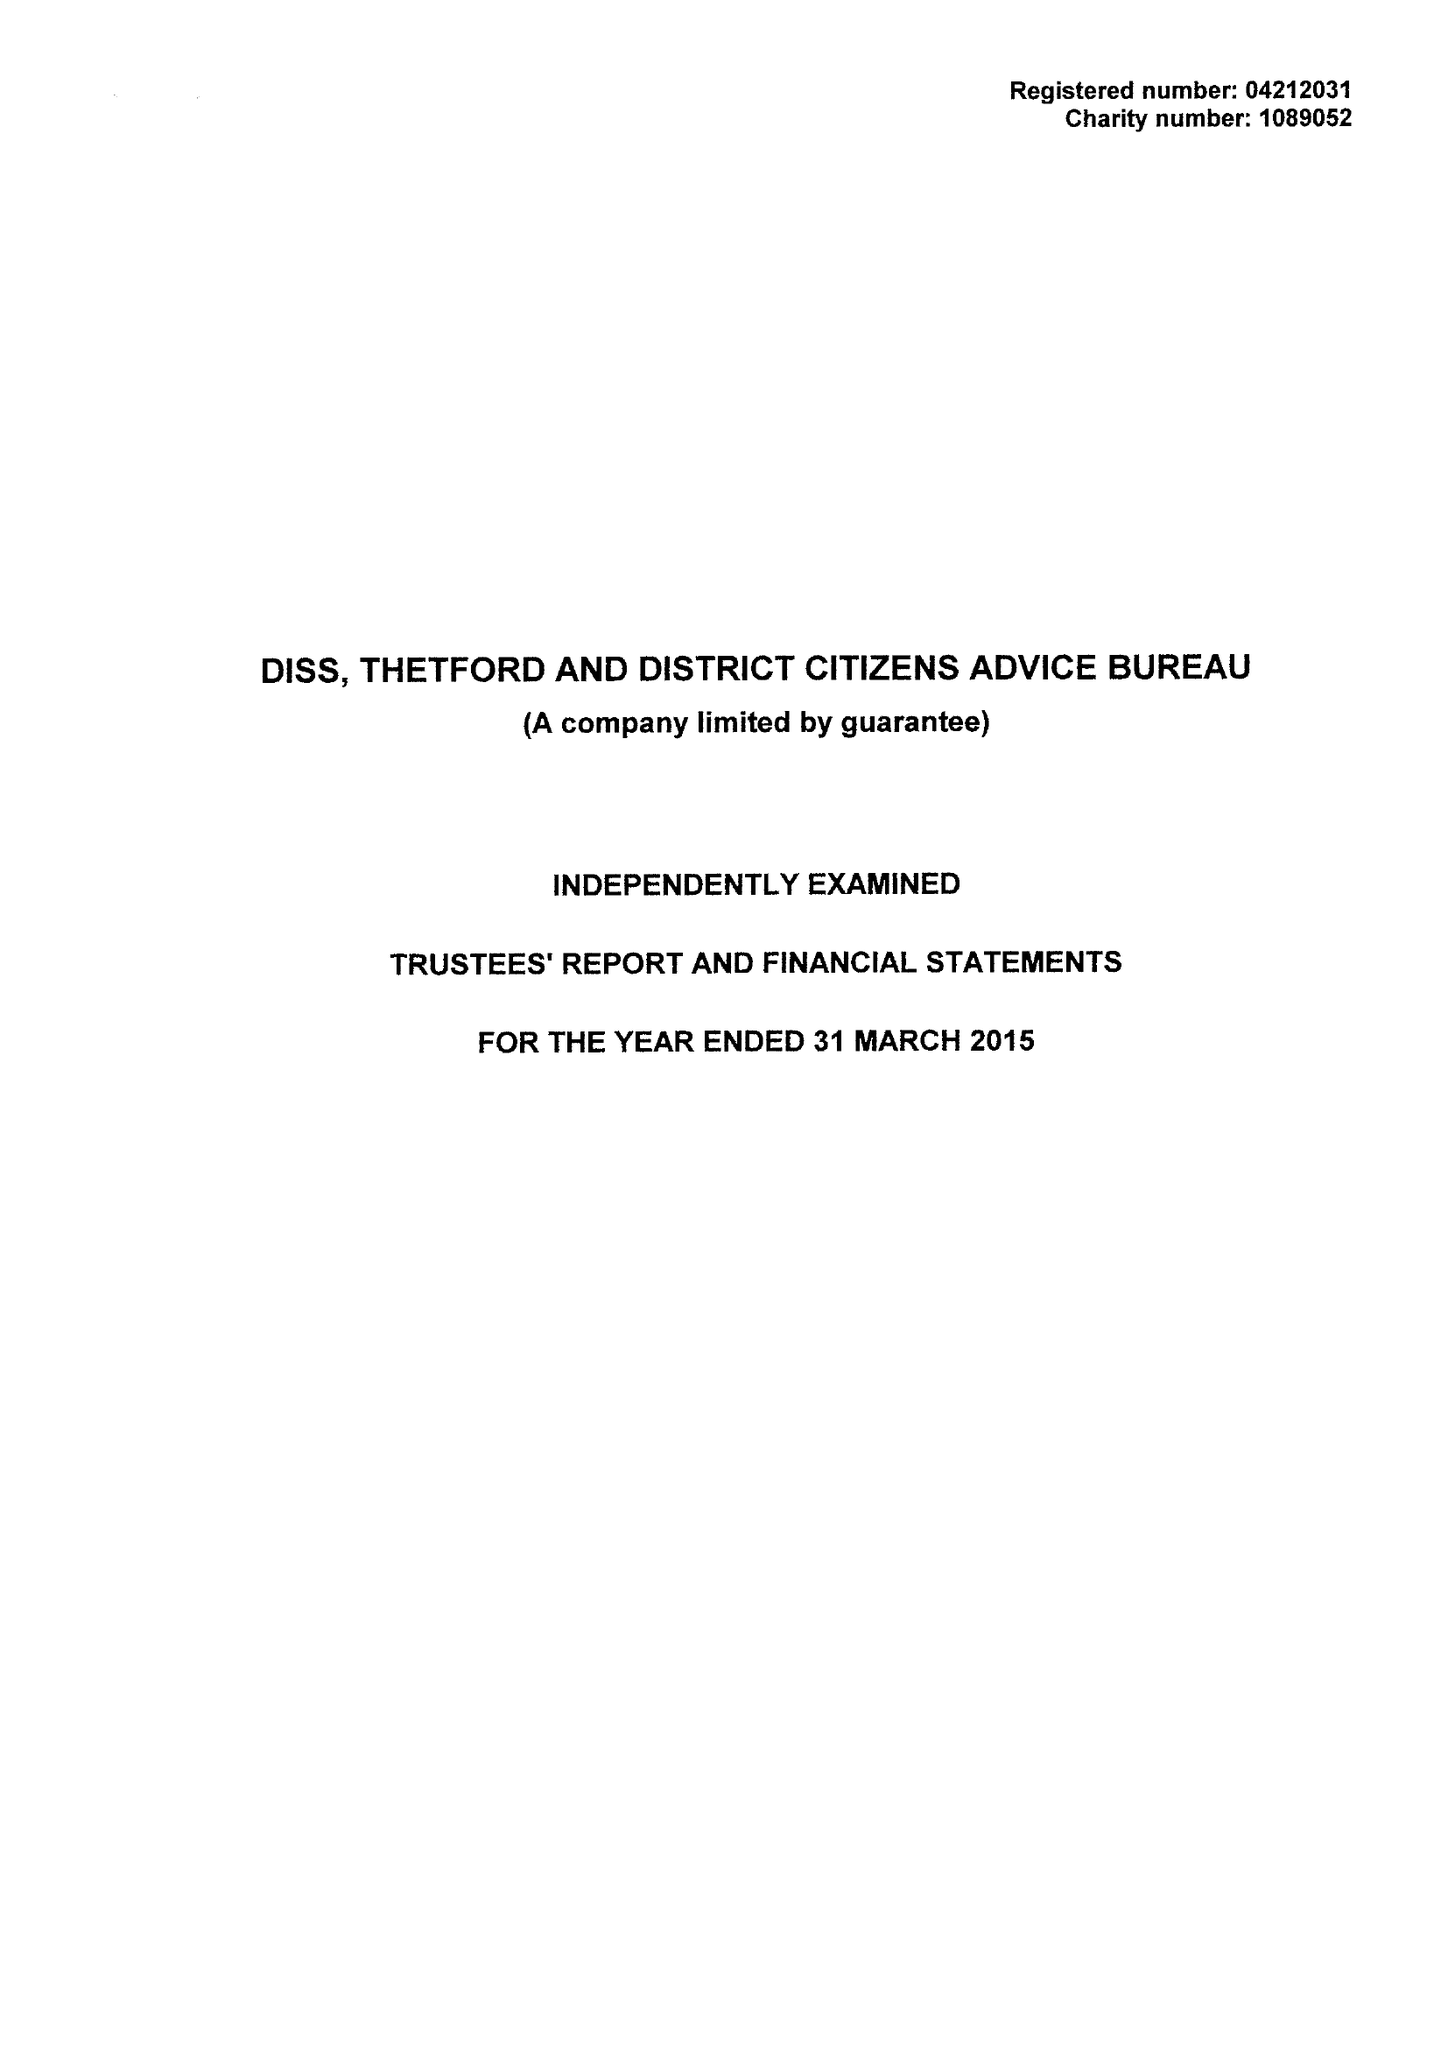What is the value for the charity_name?
Answer the question using a single word or phrase. Diss, Thetford and District Citizens Advice Bureau 